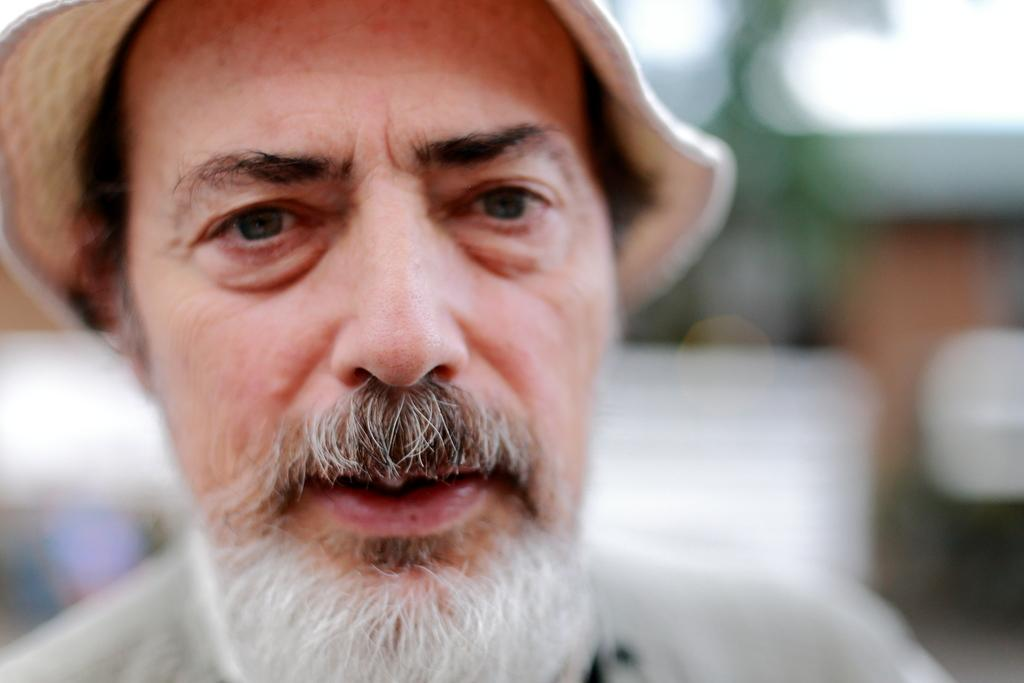What is the main subject of the image? There is a person in the image. What is the person wearing on their head? The person is wearing a hat. Can you describe the background of the image? The background of the image is blurry. Are there any cobwebs visible in the image? There is no mention of cobwebs in the provided facts, so we cannot determine if any are present in the image. 